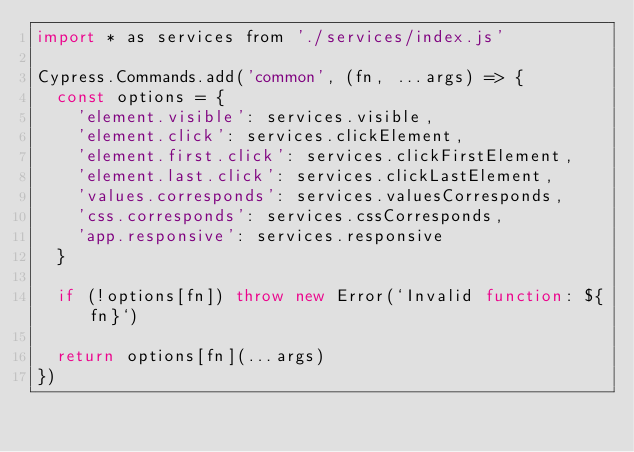<code> <loc_0><loc_0><loc_500><loc_500><_JavaScript_>import * as services from './services/index.js'

Cypress.Commands.add('common', (fn, ...args) => {
  const options = {
    'element.visible': services.visible,
    'element.click': services.clickElement,
    'element.first.click': services.clickFirstElement,
    'element.last.click': services.clickLastElement,
    'values.corresponds': services.valuesCorresponds,
    'css.corresponds': services.cssCorresponds,
    'app.responsive': services.responsive
  }

  if (!options[fn]) throw new Error(`Invalid function: ${fn}`)

  return options[fn](...args)
})
</code> 